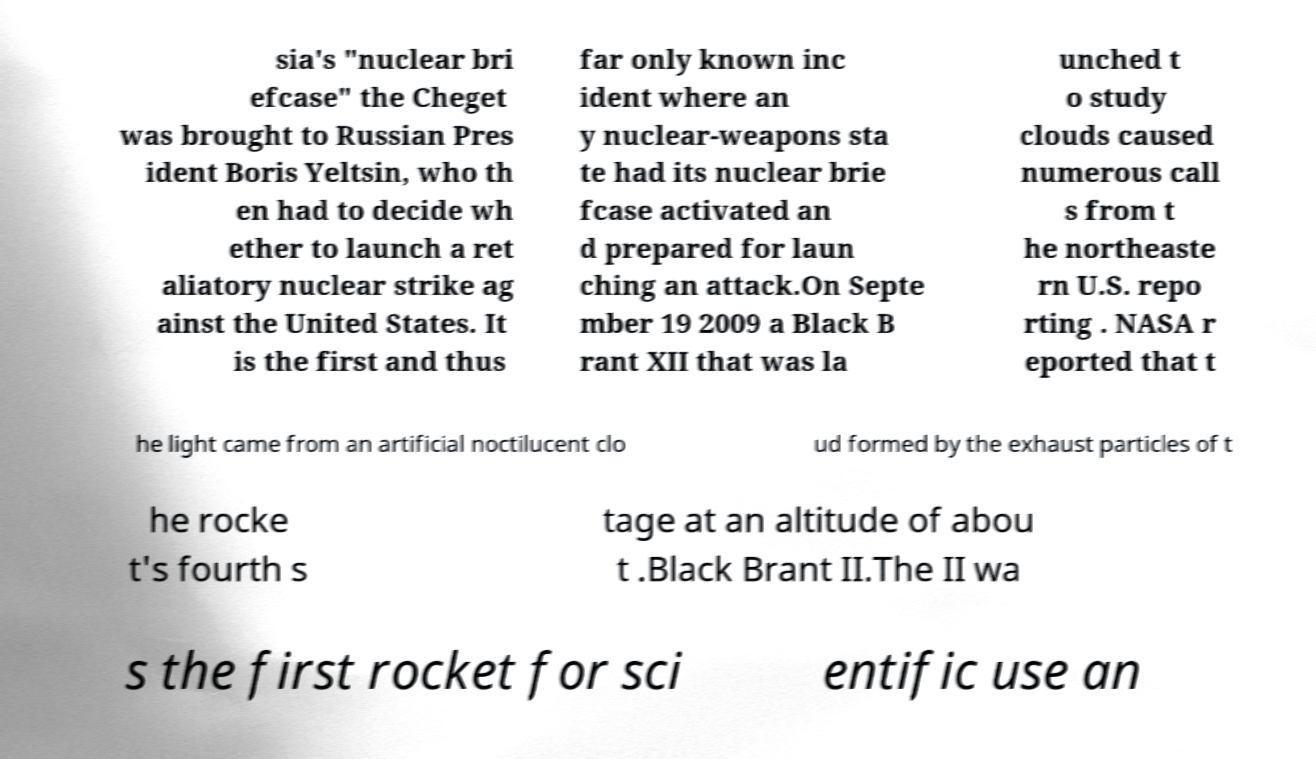I need the written content from this picture converted into text. Can you do that? sia's "nuclear bri efcase" the Cheget was brought to Russian Pres ident Boris Yeltsin, who th en had to decide wh ether to launch a ret aliatory nuclear strike ag ainst the United States. It is the first and thus far only known inc ident where an y nuclear-weapons sta te had its nuclear brie fcase activated an d prepared for laun ching an attack.On Septe mber 19 2009 a Black B rant XII that was la unched t o study clouds caused numerous call s from t he northeaste rn U.S. repo rting . NASA r eported that t he light came from an artificial noctilucent clo ud formed by the exhaust particles of t he rocke t's fourth s tage at an altitude of abou t .Black Brant II.The II wa s the first rocket for sci entific use an 